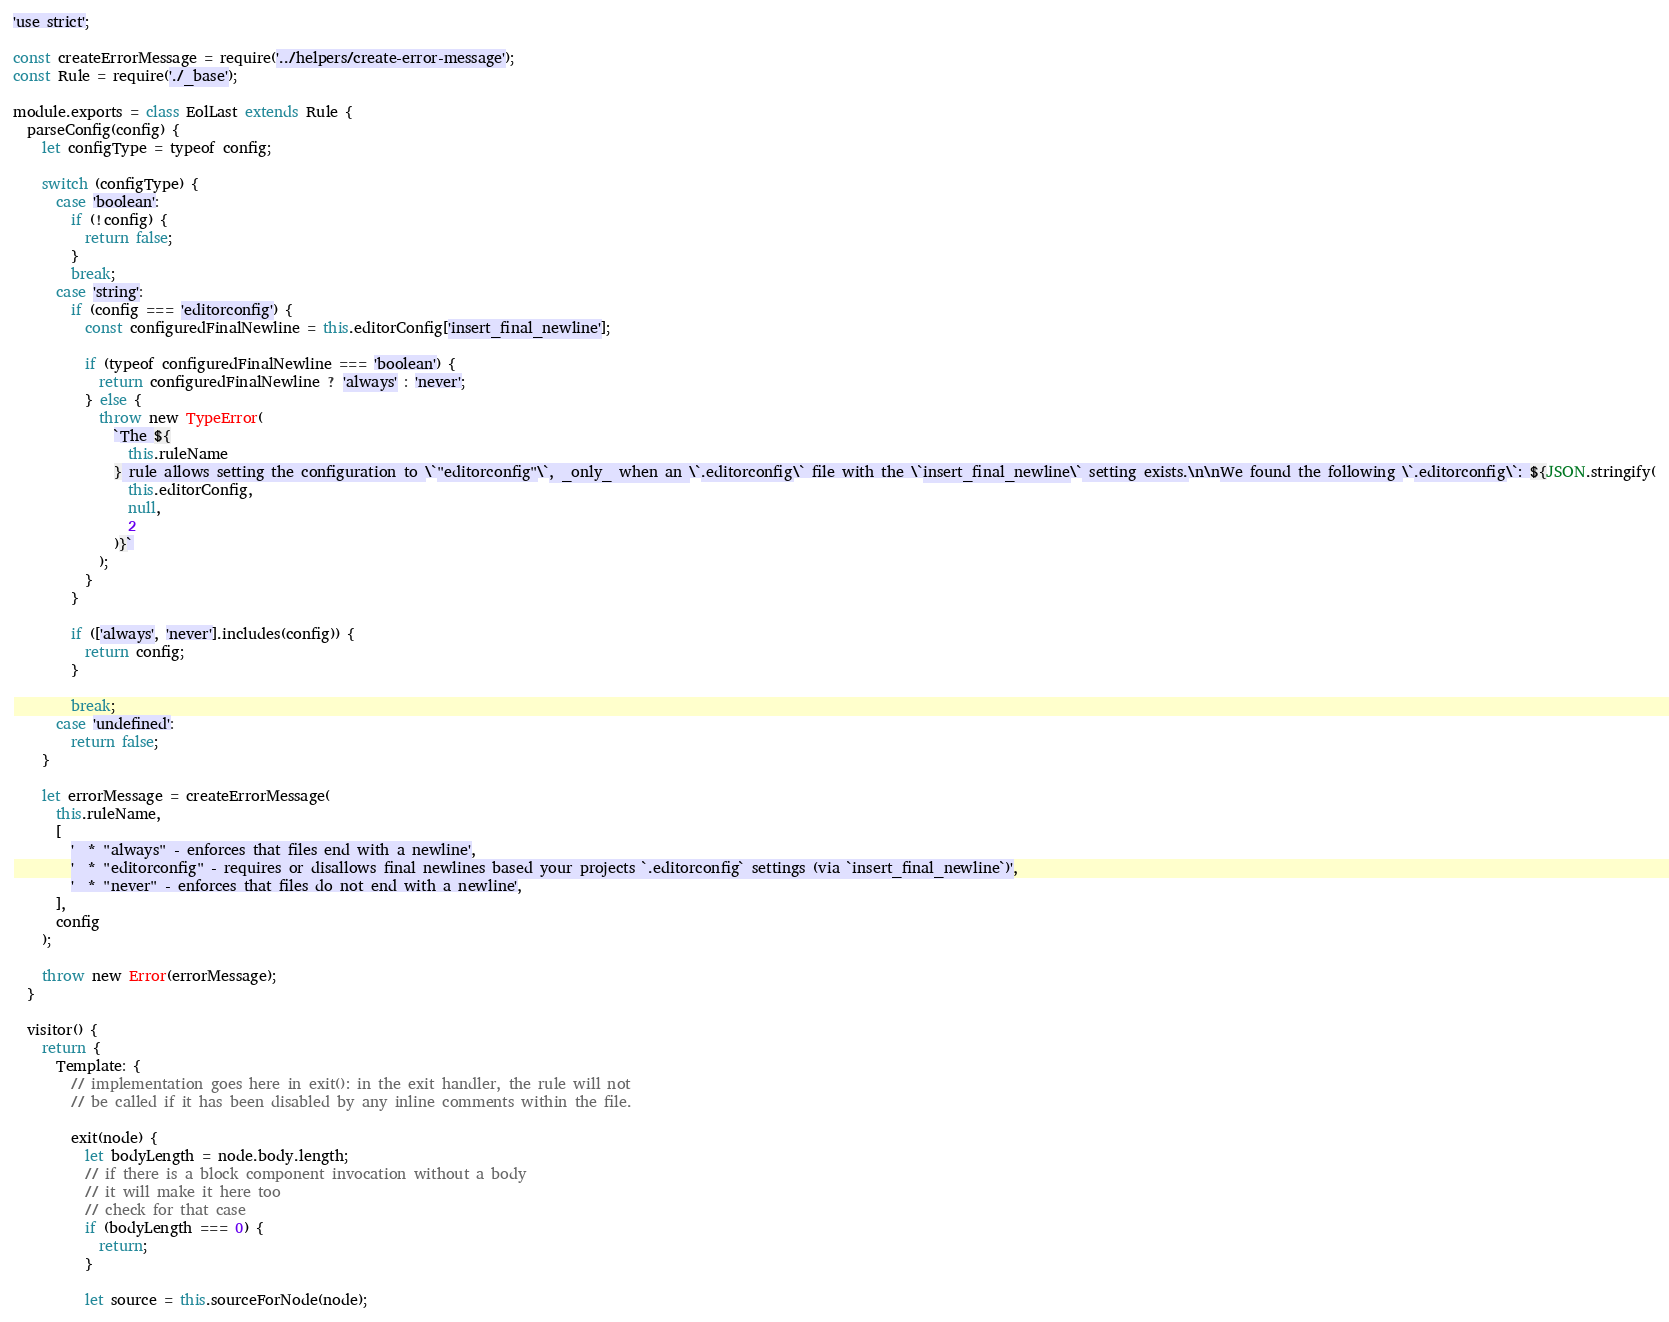<code> <loc_0><loc_0><loc_500><loc_500><_JavaScript_>'use strict';

const createErrorMessage = require('../helpers/create-error-message');
const Rule = require('./_base');

module.exports = class EolLast extends Rule {
  parseConfig(config) {
    let configType = typeof config;

    switch (configType) {
      case 'boolean':
        if (!config) {
          return false;
        }
        break;
      case 'string':
        if (config === 'editorconfig') {
          const configuredFinalNewline = this.editorConfig['insert_final_newline'];

          if (typeof configuredFinalNewline === 'boolean') {
            return configuredFinalNewline ? 'always' : 'never';
          } else {
            throw new TypeError(
              `The ${
                this.ruleName
              } rule allows setting the configuration to \`"editorconfig"\`, _only_ when an \`.editorconfig\` file with the \`insert_final_newline\` setting exists.\n\nWe found the following \`.editorconfig\`: ${JSON.stringify(
                this.editorConfig,
                null,
                2
              )}`
            );
          }
        }

        if (['always', 'never'].includes(config)) {
          return config;
        }

        break;
      case 'undefined':
        return false;
    }

    let errorMessage = createErrorMessage(
      this.ruleName,
      [
        '  * "always" - enforces that files end with a newline',
        '  * "editorconfig" - requires or disallows final newlines based your projects `.editorconfig` settings (via `insert_final_newline`)',
        '  * "never" - enforces that files do not end with a newline',
      ],
      config
    );

    throw new Error(errorMessage);
  }

  visitor() {
    return {
      Template: {
        // implementation goes here in exit(): in the exit handler, the rule will not
        // be called if it has been disabled by any inline comments within the file.

        exit(node) {
          let bodyLength = node.body.length;
          // if there is a block component invocation without a body
          // it will make it here too
          // check for that case
          if (bodyLength === 0) {
            return;
          }

          let source = this.sourceForNode(node);
</code> 